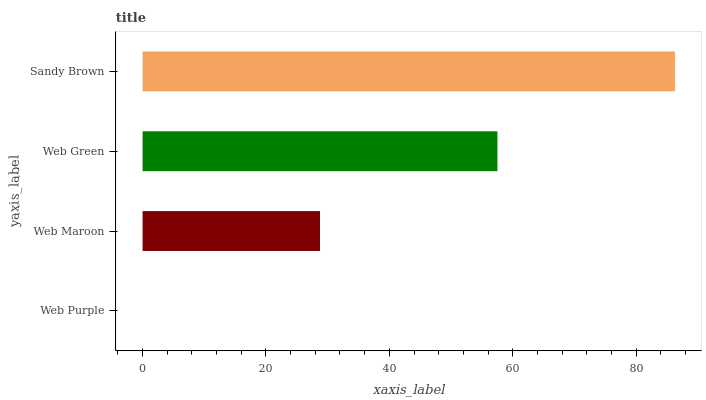Is Web Purple the minimum?
Answer yes or no. Yes. Is Sandy Brown the maximum?
Answer yes or no. Yes. Is Web Maroon the minimum?
Answer yes or no. No. Is Web Maroon the maximum?
Answer yes or no. No. Is Web Maroon greater than Web Purple?
Answer yes or no. Yes. Is Web Purple less than Web Maroon?
Answer yes or no. Yes. Is Web Purple greater than Web Maroon?
Answer yes or no. No. Is Web Maroon less than Web Purple?
Answer yes or no. No. Is Web Green the high median?
Answer yes or no. Yes. Is Web Maroon the low median?
Answer yes or no. Yes. Is Web Maroon the high median?
Answer yes or no. No. Is Sandy Brown the low median?
Answer yes or no. No. 